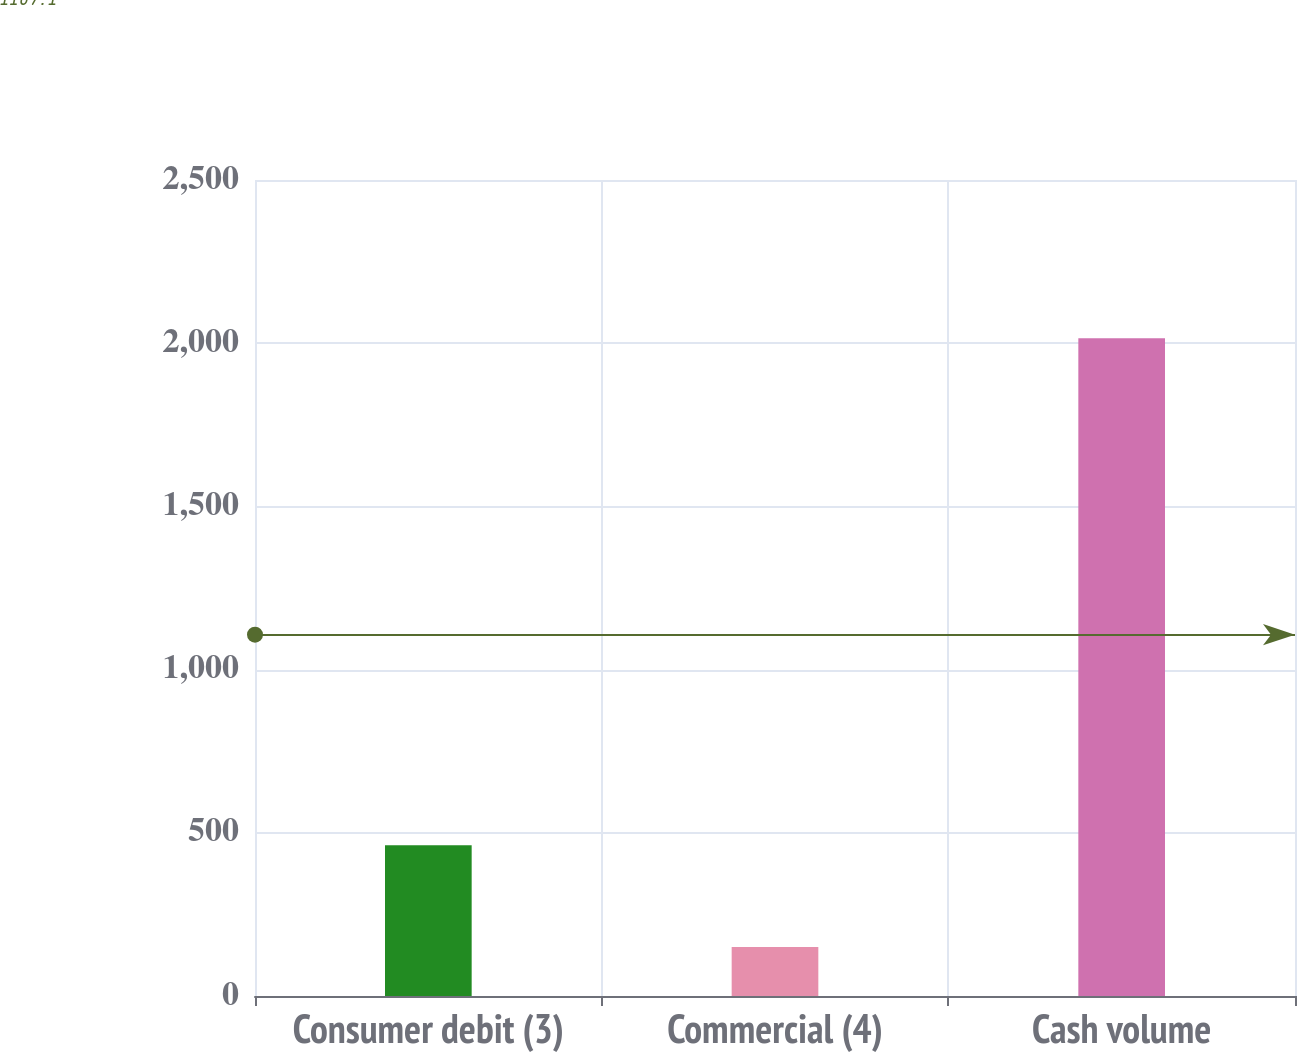<chart> <loc_0><loc_0><loc_500><loc_500><bar_chart><fcel>Consumer debit (3)<fcel>Commercial (4)<fcel>Cash volume<nl><fcel>462<fcel>150<fcel>2015<nl></chart> 